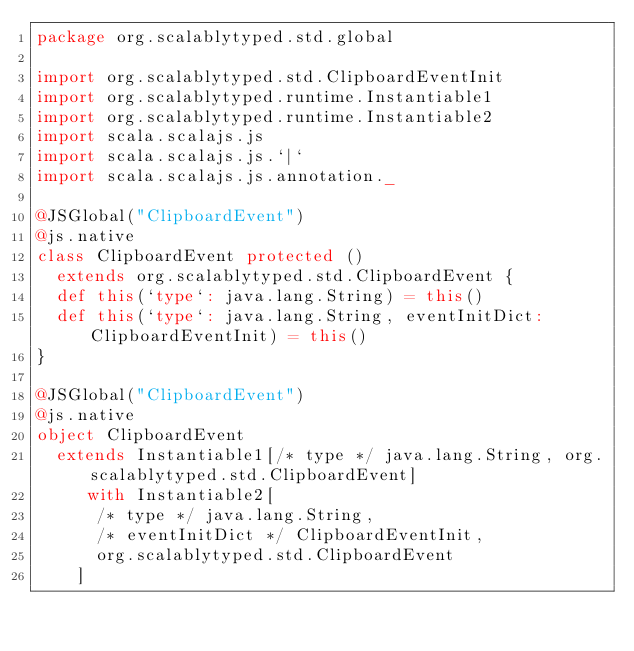Convert code to text. <code><loc_0><loc_0><loc_500><loc_500><_Scala_>package org.scalablytyped.std.global

import org.scalablytyped.std.ClipboardEventInit
import org.scalablytyped.runtime.Instantiable1
import org.scalablytyped.runtime.Instantiable2
import scala.scalajs.js
import scala.scalajs.js.`|`
import scala.scalajs.js.annotation._

@JSGlobal("ClipboardEvent")
@js.native
class ClipboardEvent protected ()
  extends org.scalablytyped.std.ClipboardEvent {
  def this(`type`: java.lang.String) = this()
  def this(`type`: java.lang.String, eventInitDict: ClipboardEventInit) = this()
}

@JSGlobal("ClipboardEvent")
@js.native
object ClipboardEvent
  extends Instantiable1[/* type */ java.lang.String, org.scalablytyped.std.ClipboardEvent]
     with Instantiable2[
      /* type */ java.lang.String, 
      /* eventInitDict */ ClipboardEventInit, 
      org.scalablytyped.std.ClipboardEvent
    ]

</code> 